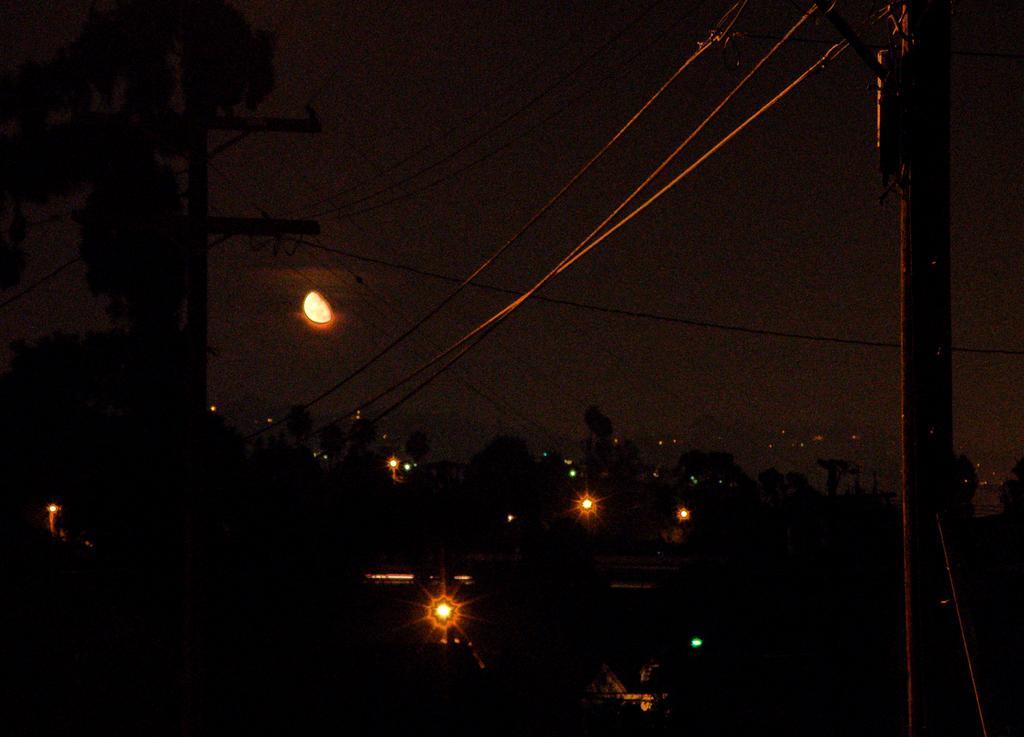In one or two sentences, can you explain what this image depicts? In this picture there are buildings and trees and there are poles and there are wires on the poles. At the top there is sky and there is a moon. 